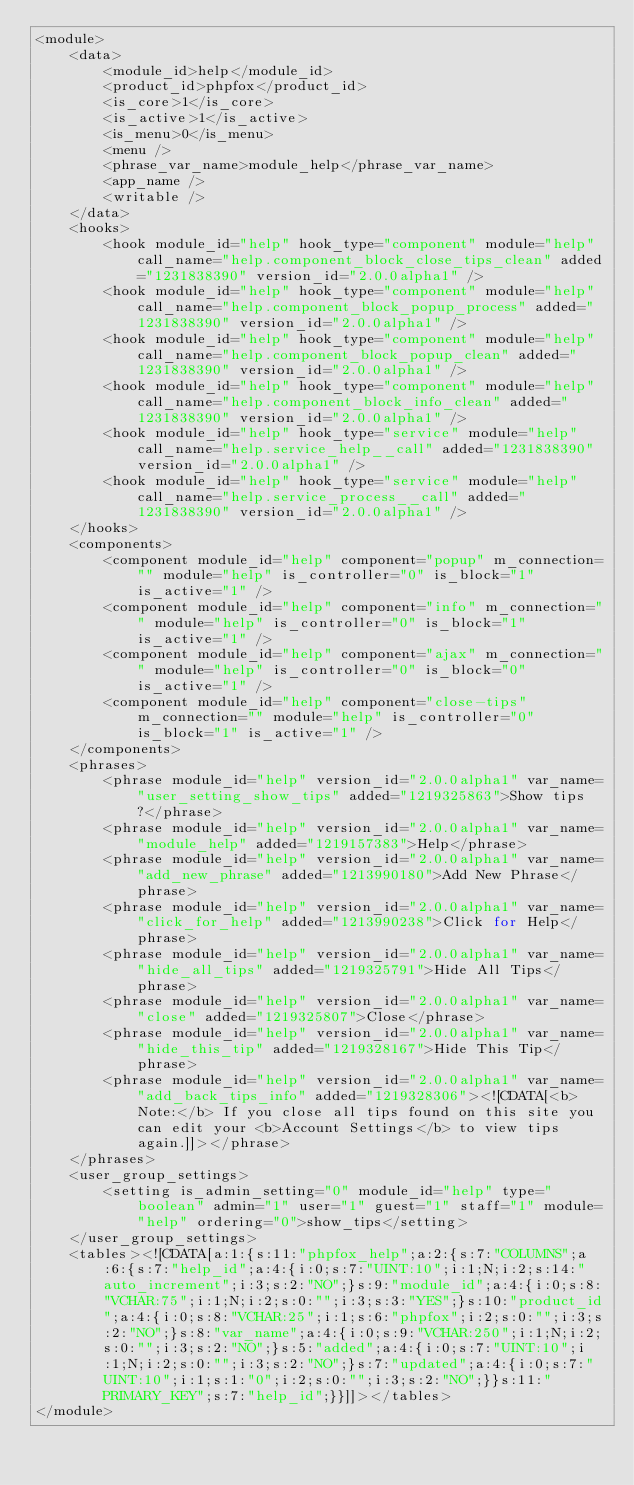<code> <loc_0><loc_0><loc_500><loc_500><_PHP_><module>
	<data>
		<module_id>help</module_id>
		<product_id>phpfox</product_id>
		<is_core>1</is_core>
		<is_active>1</is_active>
		<is_menu>0</is_menu>
		<menu />
		<phrase_var_name>module_help</phrase_var_name>
		<app_name />
		<writable />
	</data>
	<hooks>
		<hook module_id="help" hook_type="component" module="help" call_name="help.component_block_close_tips_clean" added="1231838390" version_id="2.0.0alpha1" />
		<hook module_id="help" hook_type="component" module="help" call_name="help.component_block_popup_process" added="1231838390" version_id="2.0.0alpha1" />
		<hook module_id="help" hook_type="component" module="help" call_name="help.component_block_popup_clean" added="1231838390" version_id="2.0.0alpha1" />
		<hook module_id="help" hook_type="component" module="help" call_name="help.component_block_info_clean" added="1231838390" version_id="2.0.0alpha1" />
		<hook module_id="help" hook_type="service" module="help" call_name="help.service_help__call" added="1231838390" version_id="2.0.0alpha1" />
		<hook module_id="help" hook_type="service" module="help" call_name="help.service_process__call" added="1231838390" version_id="2.0.0alpha1" />
	</hooks>
	<components>
		<component module_id="help" component="popup" m_connection="" module="help" is_controller="0" is_block="1" is_active="1" />
		<component module_id="help" component="info" m_connection="" module="help" is_controller="0" is_block="1" is_active="1" />
		<component module_id="help" component="ajax" m_connection="" module="help" is_controller="0" is_block="0" is_active="1" />
		<component module_id="help" component="close-tips" m_connection="" module="help" is_controller="0" is_block="1" is_active="1" />
	</components>
	<phrases>
		<phrase module_id="help" version_id="2.0.0alpha1" var_name="user_setting_show_tips" added="1219325863">Show tips?</phrase>
		<phrase module_id="help" version_id="2.0.0alpha1" var_name="module_help" added="1219157383">Help</phrase>
		<phrase module_id="help" version_id="2.0.0alpha1" var_name="add_new_phrase" added="1213990180">Add New Phrase</phrase>
		<phrase module_id="help" version_id="2.0.0alpha1" var_name="click_for_help" added="1213990238">Click for Help</phrase>
		<phrase module_id="help" version_id="2.0.0alpha1" var_name="hide_all_tips" added="1219325791">Hide All Tips</phrase>
		<phrase module_id="help" version_id="2.0.0alpha1" var_name="close" added="1219325807">Close</phrase>
		<phrase module_id="help" version_id="2.0.0alpha1" var_name="hide_this_tip" added="1219328167">Hide This Tip</phrase>
		<phrase module_id="help" version_id="2.0.0alpha1" var_name="add_back_tips_info" added="1219328306"><![CDATA[<b>Note:</b> If you close all tips found on this site you can edit your <b>Account Settings</b> to view tips again.]]></phrase>
	</phrases>
	<user_group_settings>
		<setting is_admin_setting="0" module_id="help" type="boolean" admin="1" user="1" guest="1" staff="1" module="help" ordering="0">show_tips</setting>
	</user_group_settings>
	<tables><![CDATA[a:1:{s:11:"phpfox_help";a:2:{s:7:"COLUMNS";a:6:{s:7:"help_id";a:4:{i:0;s:7:"UINT:10";i:1;N;i:2;s:14:"auto_increment";i:3;s:2:"NO";}s:9:"module_id";a:4:{i:0;s:8:"VCHAR:75";i:1;N;i:2;s:0:"";i:3;s:3:"YES";}s:10:"product_id";a:4:{i:0;s:8:"VCHAR:25";i:1;s:6:"phpfox";i:2;s:0:"";i:3;s:2:"NO";}s:8:"var_name";a:4:{i:0;s:9:"VCHAR:250";i:1;N;i:2;s:0:"";i:3;s:2:"NO";}s:5:"added";a:4:{i:0;s:7:"UINT:10";i:1;N;i:2;s:0:"";i:3;s:2:"NO";}s:7:"updated";a:4:{i:0;s:7:"UINT:10";i:1;s:1:"0";i:2;s:0:"";i:3;s:2:"NO";}}s:11:"PRIMARY_KEY";s:7:"help_id";}}]]></tables>
</module></code> 